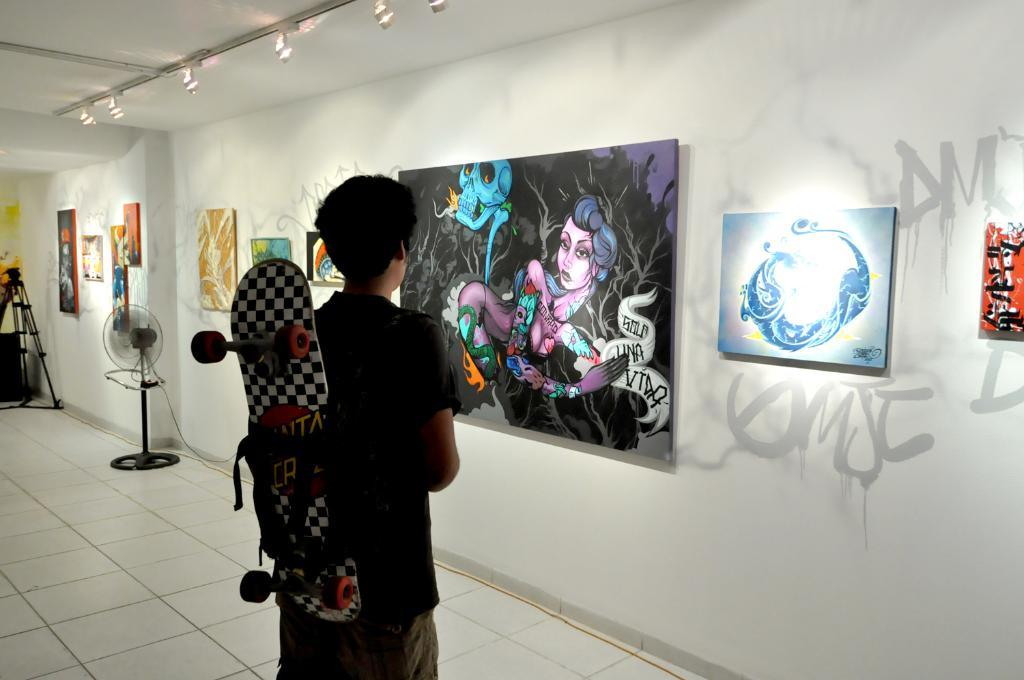What is the main subject of the image? There is a person standing in the image. What is the person wearing in the image? The person is wearing a skateboard. What can be seen on the wall in the image? There are boards on the wall in the image. What is present on the floor in the image? There is a table fan on the floor in the image. What type of impulse can be seen guiding the person in the image? There is no impulse guiding the person in the image; it is a still image. Can you tell me the name of the person's parent in the image? There is no information about the person's parent in the image. 